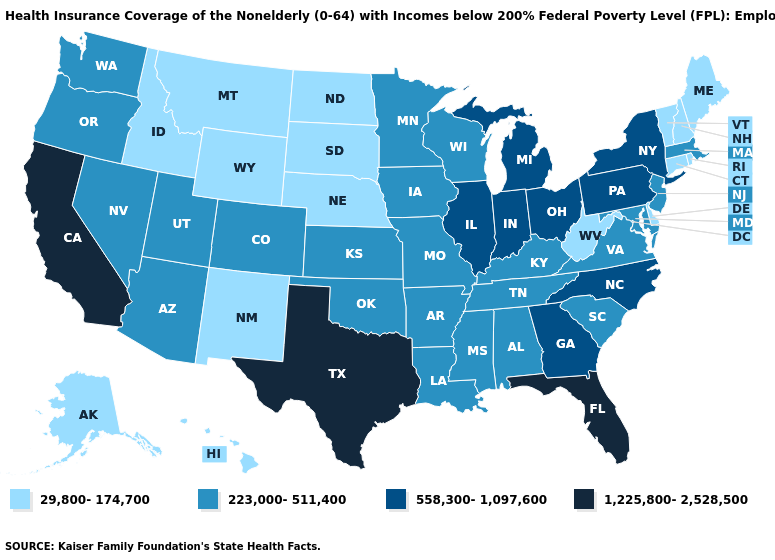Which states have the highest value in the USA?
Keep it brief. California, Florida, Texas. Among the states that border Oklahoma , does Texas have the lowest value?
Be succinct. No. Name the states that have a value in the range 1,225,800-2,528,500?
Short answer required. California, Florida, Texas. Does Florida have the highest value in the USA?
Write a very short answer. Yes. What is the value of Maryland?
Concise answer only. 223,000-511,400. Which states hav the highest value in the Northeast?
Short answer required. New York, Pennsylvania. Does Wyoming have the lowest value in the USA?
Give a very brief answer. Yes. Which states have the lowest value in the USA?
Give a very brief answer. Alaska, Connecticut, Delaware, Hawaii, Idaho, Maine, Montana, Nebraska, New Hampshire, New Mexico, North Dakota, Rhode Island, South Dakota, Vermont, West Virginia, Wyoming. Does Nebraska have the lowest value in the MidWest?
Keep it brief. Yes. Does Arizona have the highest value in the West?
Quick response, please. No. Does the map have missing data?
Keep it brief. No. What is the value of Idaho?
Be succinct. 29,800-174,700. Does Kansas have the highest value in the MidWest?
Keep it brief. No. Name the states that have a value in the range 29,800-174,700?
Be succinct. Alaska, Connecticut, Delaware, Hawaii, Idaho, Maine, Montana, Nebraska, New Hampshire, New Mexico, North Dakota, Rhode Island, South Dakota, Vermont, West Virginia, Wyoming. Name the states that have a value in the range 1,225,800-2,528,500?
Quick response, please. California, Florida, Texas. 